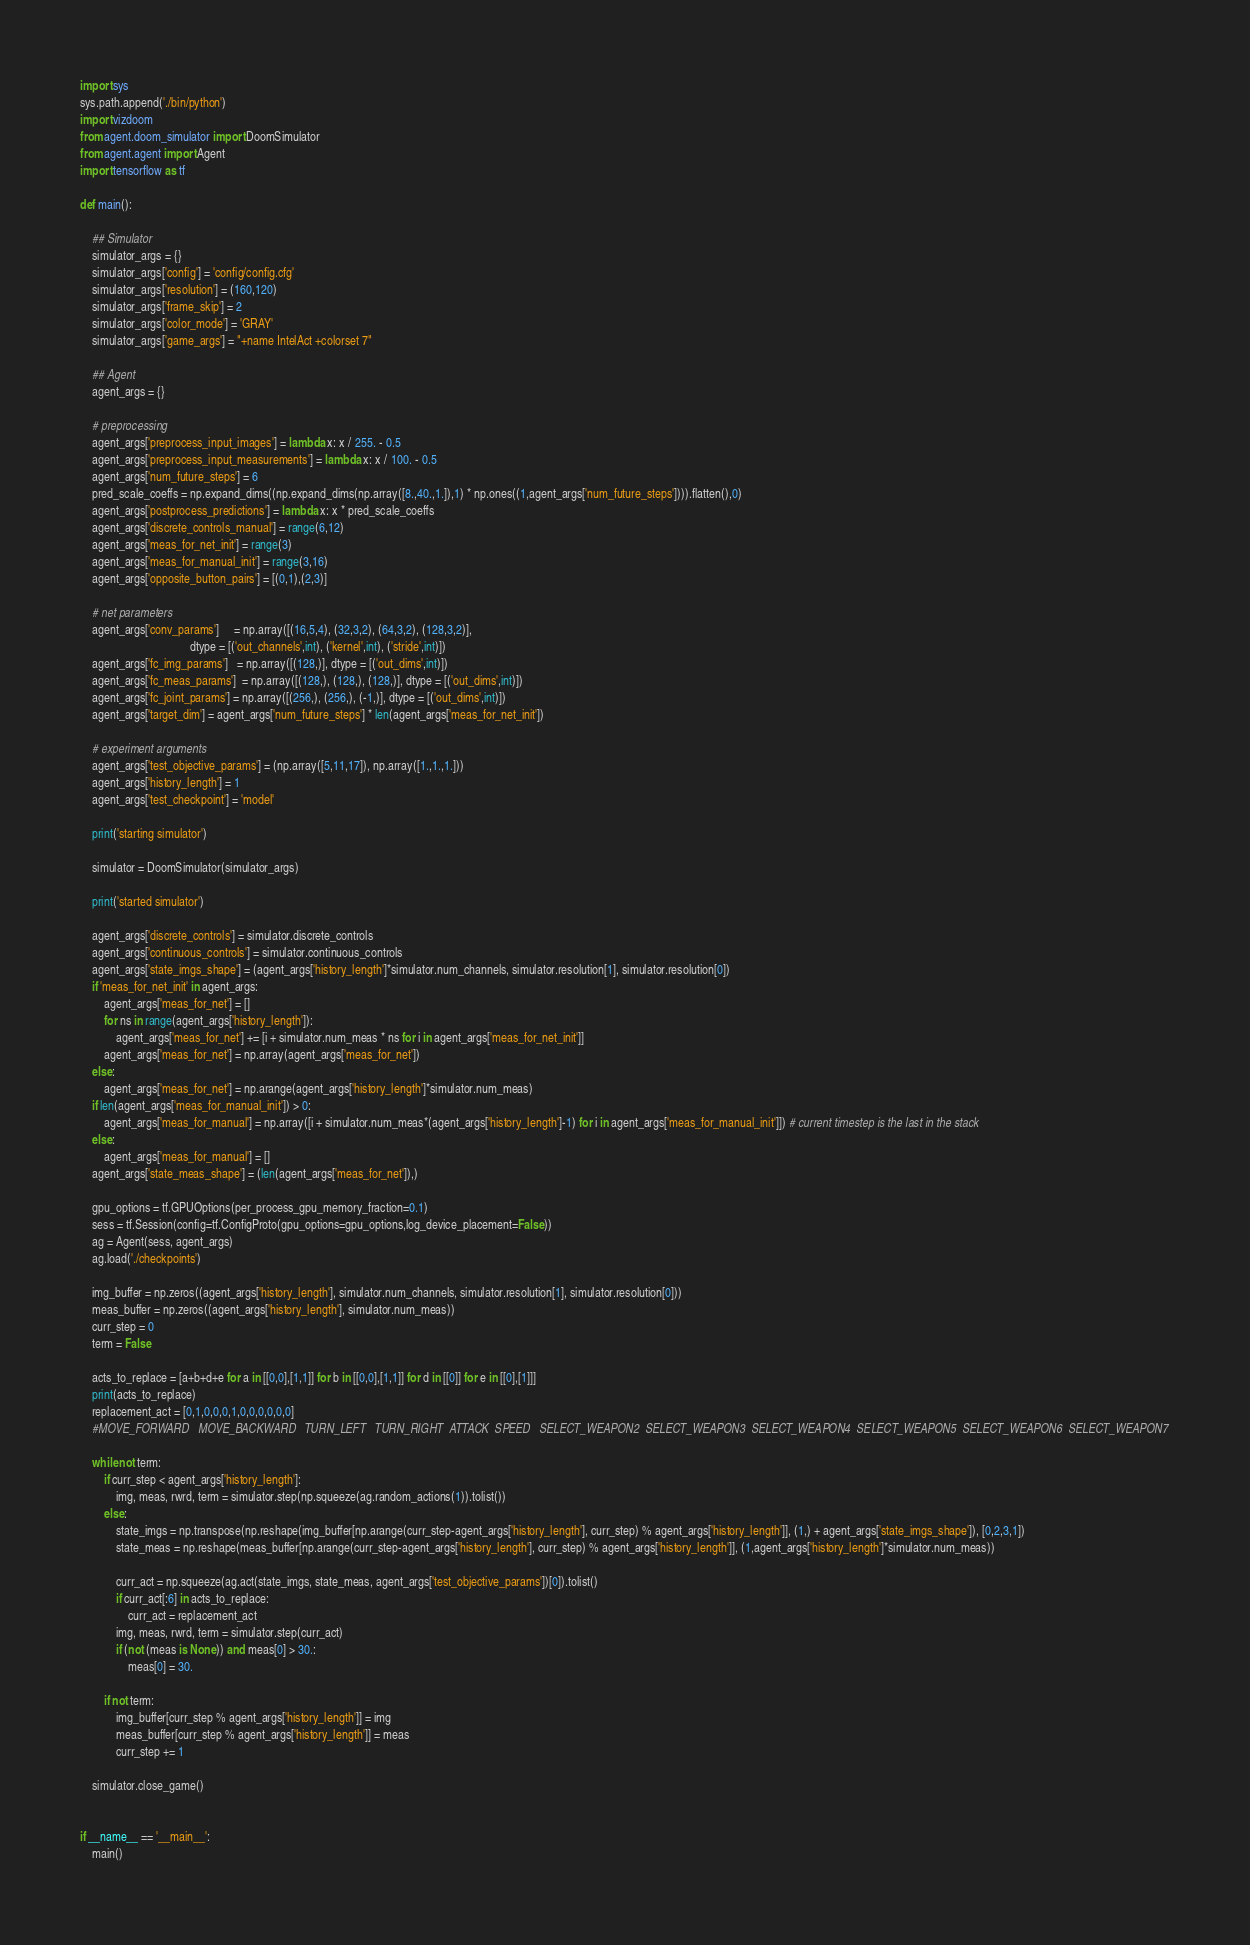Convert code to text. <code><loc_0><loc_0><loc_500><loc_500><_Python_>import sys
sys.path.append('./bin/python')
import vizdoom 
from agent.doom_simulator import DoomSimulator
from agent.agent import Agent
import tensorflow as tf

def main():
    
    ## Simulator
    simulator_args = {}
    simulator_args['config'] = 'config/config.cfg'
    simulator_args['resolution'] = (160,120)
    simulator_args['frame_skip'] = 2
    simulator_args['color_mode'] = 'GRAY'   
    simulator_args['game_args'] = "+name IntelAct +colorset 7"
        
    ## Agent    
    agent_args = {}
    
    # preprocessing
    agent_args['preprocess_input_images'] = lambda x: x / 255. - 0.5
    agent_args['preprocess_input_measurements'] = lambda x: x / 100. - 0.5
    agent_args['num_future_steps'] = 6
    pred_scale_coeffs = np.expand_dims((np.expand_dims(np.array([8.,40.,1.]),1) * np.ones((1,agent_args['num_future_steps']))).flatten(),0)
    agent_args['postprocess_predictions'] = lambda x: x * pred_scale_coeffs
    agent_args['discrete_controls_manual'] = range(6,12) 
    agent_args['meas_for_net_init'] = range(3)
    agent_args['meas_for_manual_init'] = range(3,16)
    agent_args['opposite_button_pairs'] = [(0,1),(2,3)]
    
    # net parameters
    agent_args['conv_params']     = np.array([(16,5,4), (32,3,2), (64,3,2), (128,3,2)],
                                     dtype = [('out_channels',int), ('kernel',int), ('stride',int)])
    agent_args['fc_img_params']   = np.array([(128,)], dtype = [('out_dims',int)])
    agent_args['fc_meas_params']  = np.array([(128,), (128,), (128,)], dtype = [('out_dims',int)]) 
    agent_args['fc_joint_params'] = np.array([(256,), (256,), (-1,)], dtype = [('out_dims',int)])   
    agent_args['target_dim'] = agent_args['num_future_steps'] * len(agent_args['meas_for_net_init'])
    
    # experiment arguments
    agent_args['test_objective_params'] = (np.array([5,11,17]), np.array([1.,1.,1.]))
    agent_args['history_length'] = 1
    agent_args['test_checkpoint'] = 'model'
    
    print('starting simulator')

    simulator = DoomSimulator(simulator_args)
    
    print('started simulator')

    agent_args['discrete_controls'] = simulator.discrete_controls
    agent_args['continuous_controls'] = simulator.continuous_controls
    agent_args['state_imgs_shape'] = (agent_args['history_length']*simulator.num_channels, simulator.resolution[1], simulator.resolution[0])
    if 'meas_for_net_init' in agent_args:
        agent_args['meas_for_net'] = []
        for ns in range(agent_args['history_length']):
            agent_args['meas_for_net'] += [i + simulator.num_meas * ns for i in agent_args['meas_for_net_init']]
        agent_args['meas_for_net'] = np.array(agent_args['meas_for_net'])
    else:
        agent_args['meas_for_net'] = np.arange(agent_args['history_length']*simulator.num_meas)
    if len(agent_args['meas_for_manual_init']) > 0:
        agent_args['meas_for_manual'] = np.array([i + simulator.num_meas*(agent_args['history_length']-1) for i in agent_args['meas_for_manual_init']]) # current timestep is the last in the stack
    else:
        agent_args['meas_for_manual'] = []
    agent_args['state_meas_shape'] = (len(agent_args['meas_for_net']),)
    
    gpu_options = tf.GPUOptions(per_process_gpu_memory_fraction=0.1)
    sess = tf.Session(config=tf.ConfigProto(gpu_options=gpu_options,log_device_placement=False))
    ag = Agent(sess, agent_args)
    ag.load('./checkpoints')
    
    img_buffer = np.zeros((agent_args['history_length'], simulator.num_channels, simulator.resolution[1], simulator.resolution[0]))
    meas_buffer = np.zeros((agent_args['history_length'], simulator.num_meas))
    curr_step = 0
    term = False
    
    acts_to_replace = [a+b+d+e for a in [[0,0],[1,1]] for b in [[0,0],[1,1]] for d in [[0]] for e in [[0],[1]]]
    print(acts_to_replace)
    replacement_act = [0,1,0,0,0,1,0,0,0,0,0,0]
    #MOVE_FORWARD   MOVE_BACKWARD   TURN_LEFT   TURN_RIGHT  ATTACK  SPEED   SELECT_WEAPON2  SELECT_WEAPON3  SELECT_WEAPON4  SELECT_WEAPON5  SELECT_WEAPON6  SELECT_WEAPON7

    while not term:
        if curr_step < agent_args['history_length']:
            img, meas, rwrd, term = simulator.step(np.squeeze(ag.random_actions(1)).tolist())
        else:
            state_imgs = np.transpose(np.reshape(img_buffer[np.arange(curr_step-agent_args['history_length'], curr_step) % agent_args['history_length']], (1,) + agent_args['state_imgs_shape']), [0,2,3,1])
            state_meas = np.reshape(meas_buffer[np.arange(curr_step-agent_args['history_length'], curr_step) % agent_args['history_length']], (1,agent_args['history_length']*simulator.num_meas))

            curr_act = np.squeeze(ag.act(state_imgs, state_meas, agent_args['test_objective_params'])[0]).tolist()
            if curr_act[:6] in acts_to_replace:
                curr_act = replacement_act
            img, meas, rwrd, term = simulator.step(curr_act)
            if (not (meas is None)) and meas[0] > 30.:
                meas[0] = 30.
            
        if not term:
            img_buffer[curr_step % agent_args['history_length']] = img
            meas_buffer[curr_step % agent_args['history_length']] = meas
            curr_step += 1
                
    simulator.close_game()


if __name__ == '__main__':
    main()
</code> 